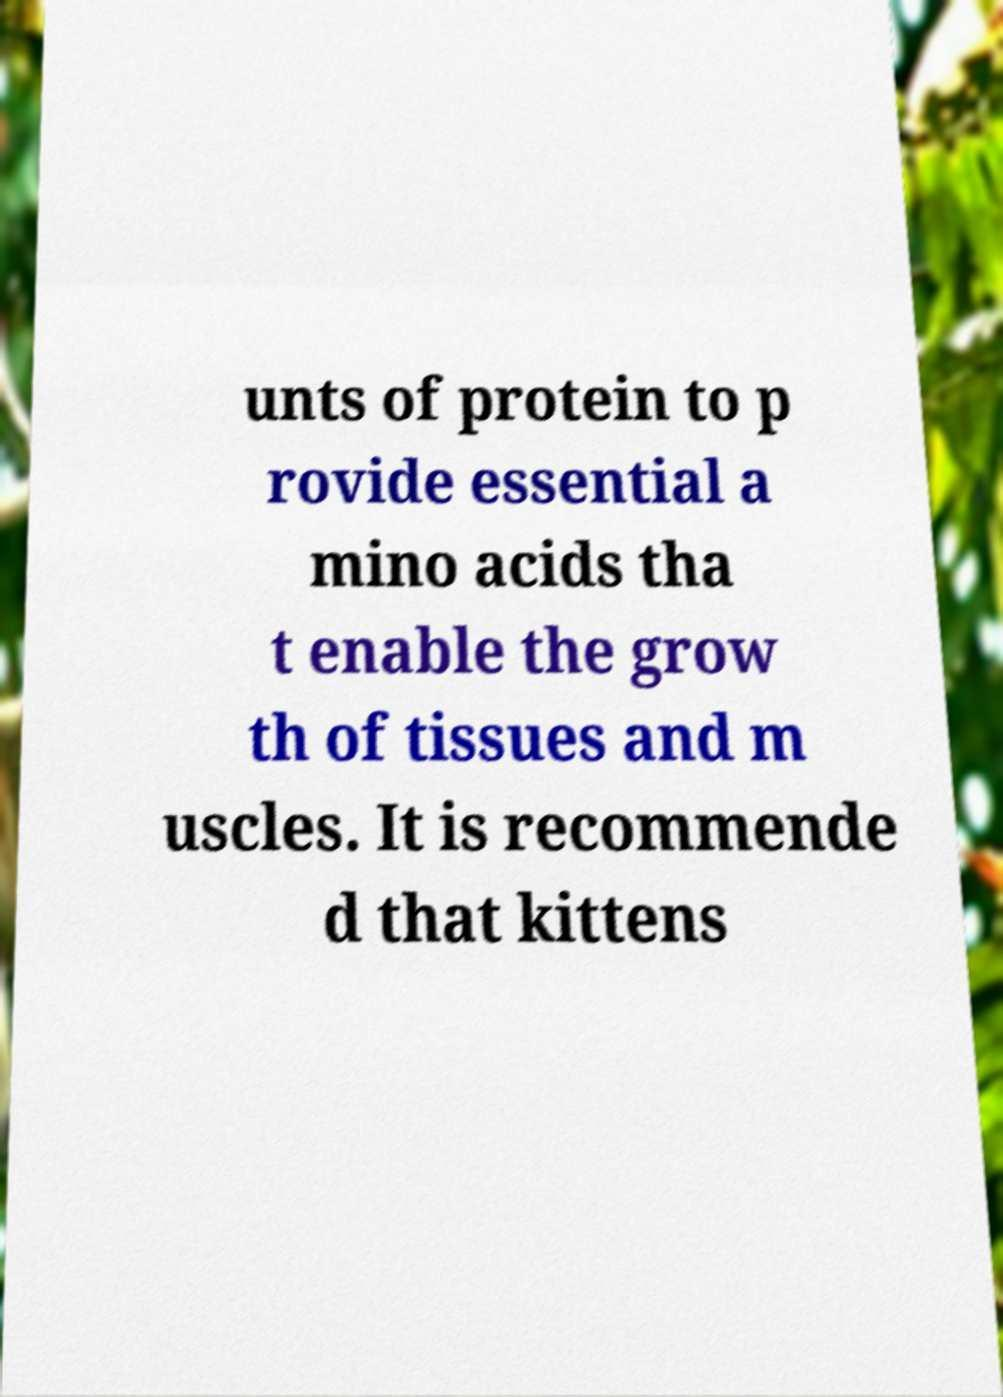Please read and relay the text visible in this image. What does it say? unts of protein to p rovide essential a mino acids tha t enable the grow th of tissues and m uscles. It is recommende d that kittens 